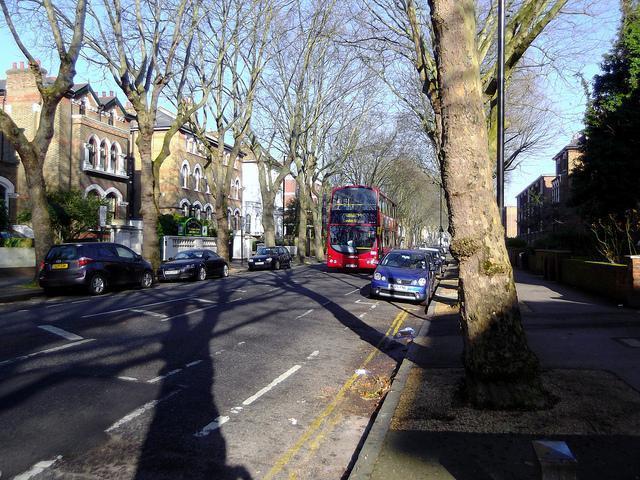Why are the cars lined up along the curb?
From the following four choices, select the correct answer to address the question.
Options: To vacuum, to inspect, to wash, to park. To park. 